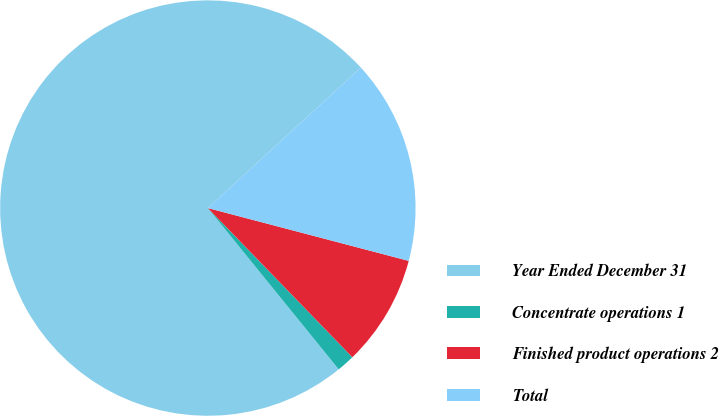Convert chart to OTSL. <chart><loc_0><loc_0><loc_500><loc_500><pie_chart><fcel>Year Ended December 31<fcel>Concentrate operations 1<fcel>Finished product operations 2<fcel>Total<nl><fcel>74.02%<fcel>1.4%<fcel>8.66%<fcel>15.92%<nl></chart> 